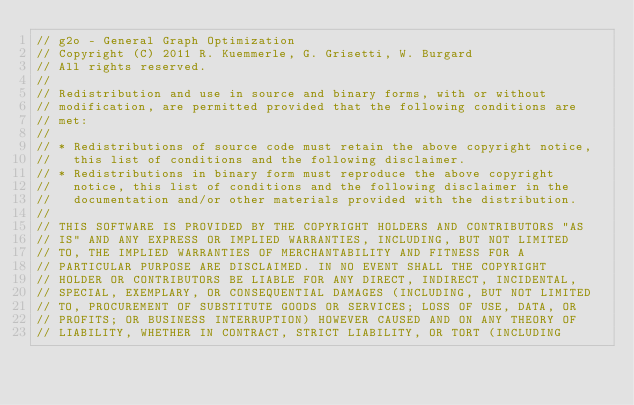Convert code to text. <code><loc_0><loc_0><loc_500><loc_500><_C_>// g2o - General Graph Optimization
// Copyright (C) 2011 R. Kuemmerle, G. Grisetti, W. Burgard
// All rights reserved.
//
// Redistribution and use in source and binary forms, with or without
// modification, are permitted provided that the following conditions are
// met:
//
// * Redistributions of source code must retain the above copyright notice,
//   this list of conditions and the following disclaimer.
// * Redistributions in binary form must reproduce the above copyright
//   notice, this list of conditions and the following disclaimer in the
//   documentation and/or other materials provided with the distribution.
//
// THIS SOFTWARE IS PROVIDED BY THE COPYRIGHT HOLDERS AND CONTRIBUTORS "AS
// IS" AND ANY EXPRESS OR IMPLIED WARRANTIES, INCLUDING, BUT NOT LIMITED
// TO, THE IMPLIED WARRANTIES OF MERCHANTABILITY AND FITNESS FOR A
// PARTICULAR PURPOSE ARE DISCLAIMED. IN NO EVENT SHALL THE COPYRIGHT
// HOLDER OR CONTRIBUTORS BE LIABLE FOR ANY DIRECT, INDIRECT, INCIDENTAL,
// SPECIAL, EXEMPLARY, OR CONSEQUENTIAL DAMAGES (INCLUDING, BUT NOT LIMITED
// TO, PROCUREMENT OF SUBSTITUTE GOODS OR SERVICES; LOSS OF USE, DATA, OR
// PROFITS; OR BUSINESS INTERRUPTION) HOWEVER CAUSED AND ON ANY THEORY OF
// LIABILITY, WHETHER IN CONTRACT, STRICT LIABILITY, OR TORT (INCLUDING</code> 